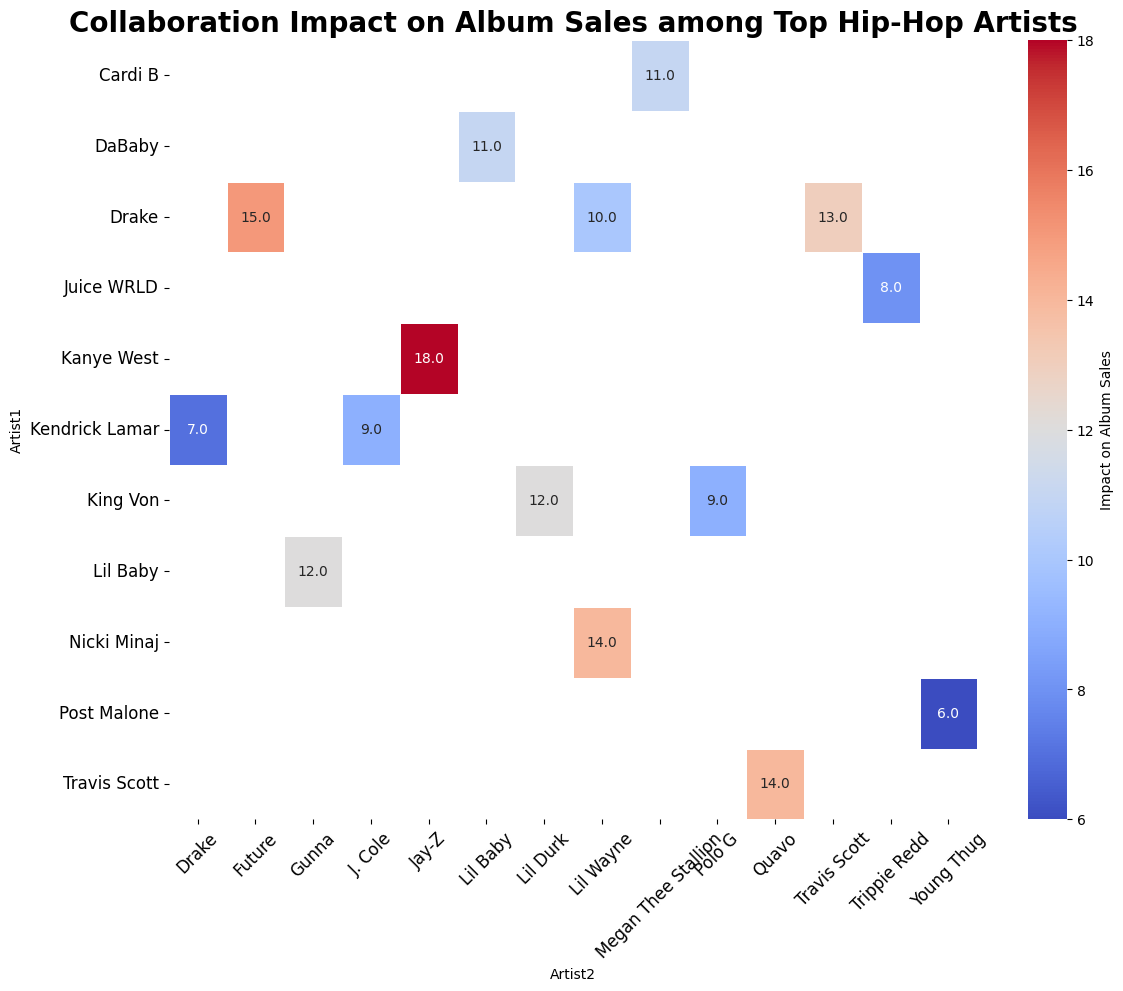Which collaboration has the highest impact on album sales? Look at the heatmap for the highest numerical value indicating the impact on album sales. This value is 18, found at the intersection of Kanye West and Jay-Z.
Answer: Kanye West and Jay-Z Which collaboration has a higher impact on album sales: Travis Scott & Quavo or Drake & Future? Compare the impact values for both collaborations. Travis Scott & Quavo have an impact of 14, whereas Drake & Future have an impact of 15.
Answer: Drake & Future What is the average impact on album sales for collaborations involving King Von? Identify the collaboration points involving King Von and their impacts: King Von & Lil Durk (12) and King Von & Polo G (9). The average is calculated as (12 + 9) / 2 = 10.5.
Answer: 10.5 Which artist appears most frequently in collaboration impacts? Count the number of times each artist appears in either the columns or rows of the heatmap. Drake appears the most frequently, with multiple collaborations listed.
Answer: Drake What is the total impact on album sales for all collaborations involving Kendrick Lamar? Sum the impacts of Kendrick Lamar's collaborations: Kendrick Lamar & J. Cole (9) and Kendrick Lamar & Drake (7). The total is 9 + 7 = 16.
Answer: 16 Which collaboration involving Lil Wayne has a higher impact on album sales? Lil Wayne & Drake or Lil Wayne & Nicki Minaj? Compare the impact values for collaborations involving Lil Wayne. Lil Wayne & Drake have an impact of 10 and Lil Wayne & Nicki Minaj have an impact of 14.
Answer: Lil Wayne & Nicki Minaj How does the impact on album sales for Juice WRLD & Trippie Redd compare to that of Post Malone & Young Thug? Compare the numerical impact values from the heatmap. Juice WRLD & Trippie Redd have an impact of 8, while Post Malone & Young Thug have an impact of 6.
Answer: Juice WRLD & Trippie Redd What is the highest impact value for collaborations involving female artists? Identify collaborations involving female artists and determine the highest impact. Cardi B & Megan Thee Stallion have an impact of 11. Nicki Minaj collaborations have a higher value of 14 with Lil Wayne.
Answer: 14 What is the combined impact on album sales for collaborations between Drake and other artists? Sum the impacts of Drake's collaborations: Drake & Future (15), Drake & Lil Wayne (10), Drake & Travis Scott (13), and Kendrick Lamar & Drake (7). The total is 15 + 10 + 13 + 7 = 45.
Answer: 45 Which collaboration has the least impact on album sales? Look at the heatmap for the lowest numerical value indicating the impact on album sales. This value is 6, found at the intersection of Post Malone and Young Thug.
Answer: Post Malone and Young Thug 